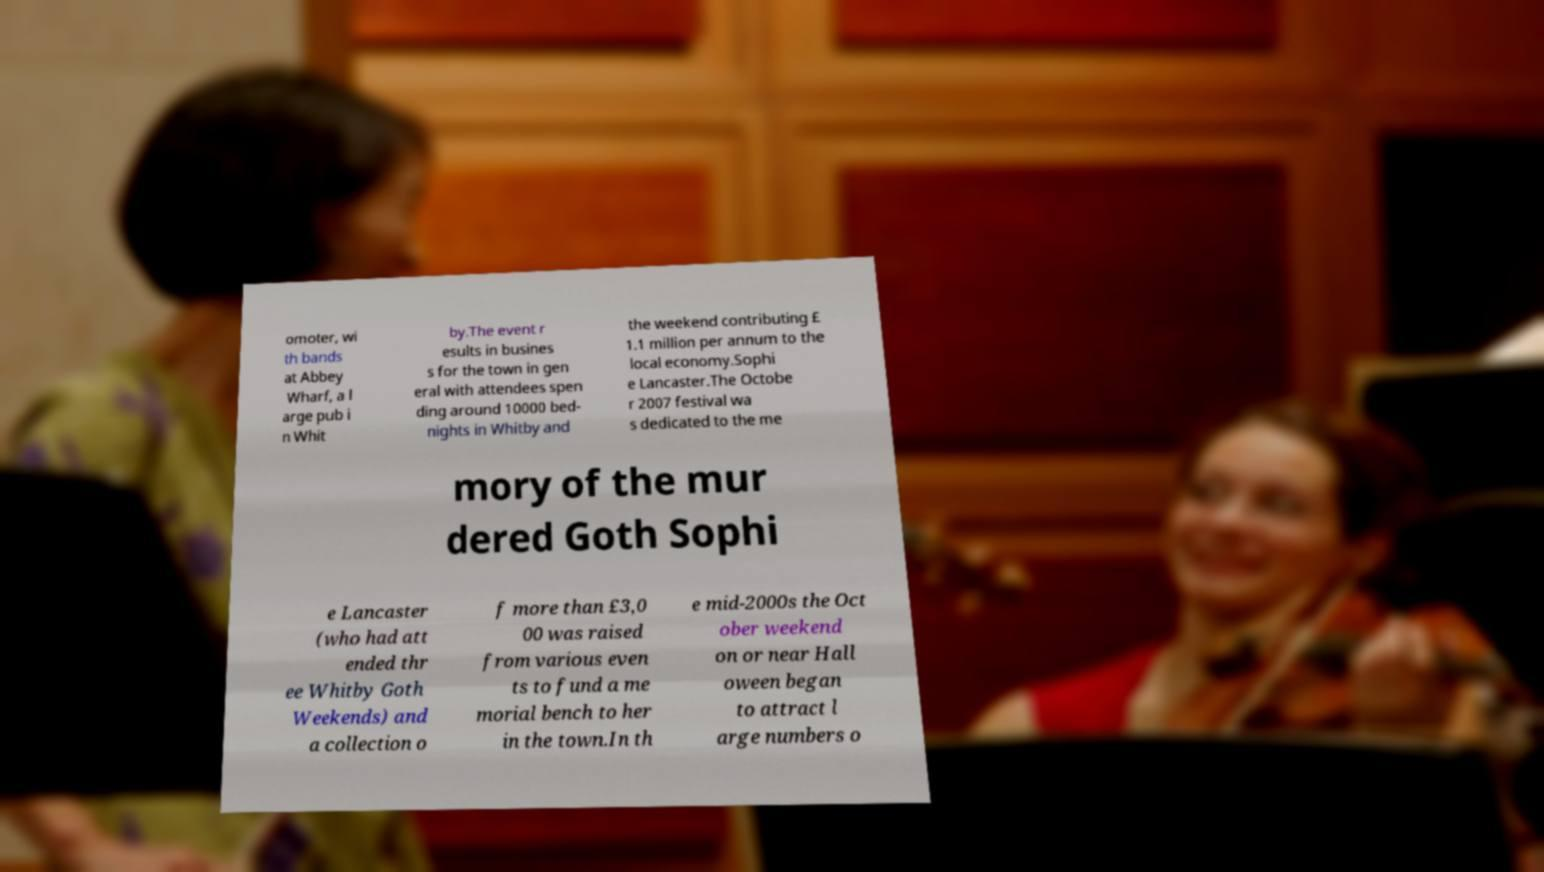There's text embedded in this image that I need extracted. Can you transcribe it verbatim? omoter, wi th bands at Abbey Wharf, a l arge pub i n Whit by.The event r esults in busines s for the town in gen eral with attendees spen ding around 10000 bed- nights in Whitby and the weekend contributing £ 1.1 million per annum to the local economy.Sophi e Lancaster.The Octobe r 2007 festival wa s dedicated to the me mory of the mur dered Goth Sophi e Lancaster (who had att ended thr ee Whitby Goth Weekends) and a collection o f more than £3,0 00 was raised from various even ts to fund a me morial bench to her in the town.In th e mid-2000s the Oct ober weekend on or near Hall oween began to attract l arge numbers o 